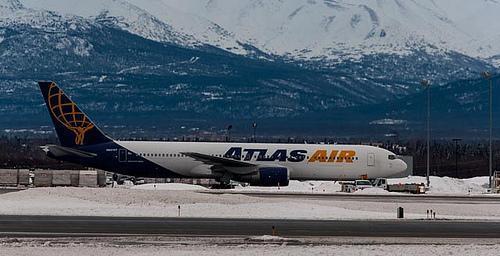How many planes are there?
Give a very brief answer. 1. 